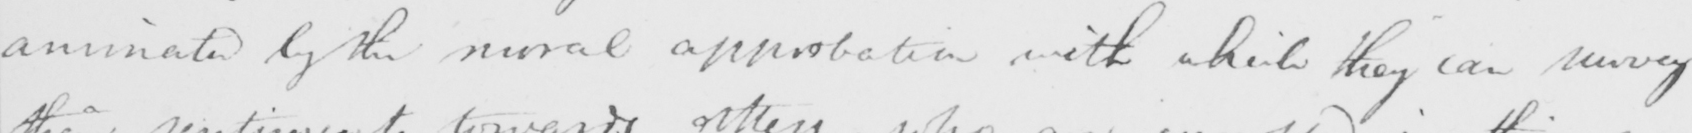Please transcribe the handwritten text in this image. animated by the moral approbation with which they can survey 